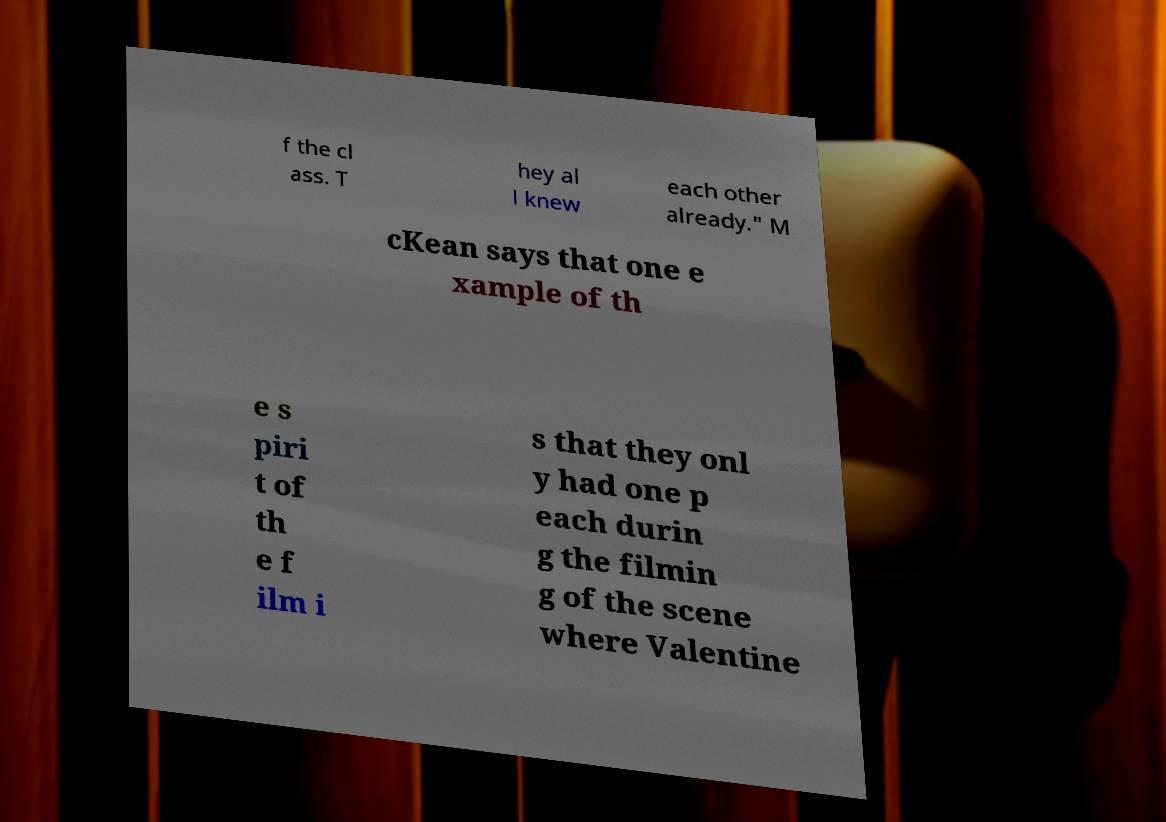Please identify and transcribe the text found in this image. f the cl ass. T hey al l knew each other already." M cKean says that one e xample of th e s piri t of th e f ilm i s that they onl y had one p each durin g the filmin g of the scene where Valentine 